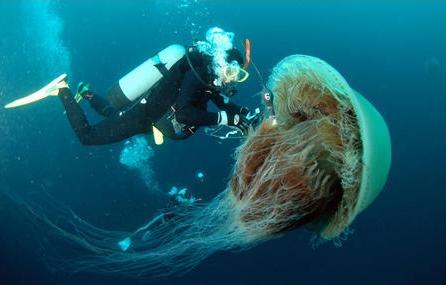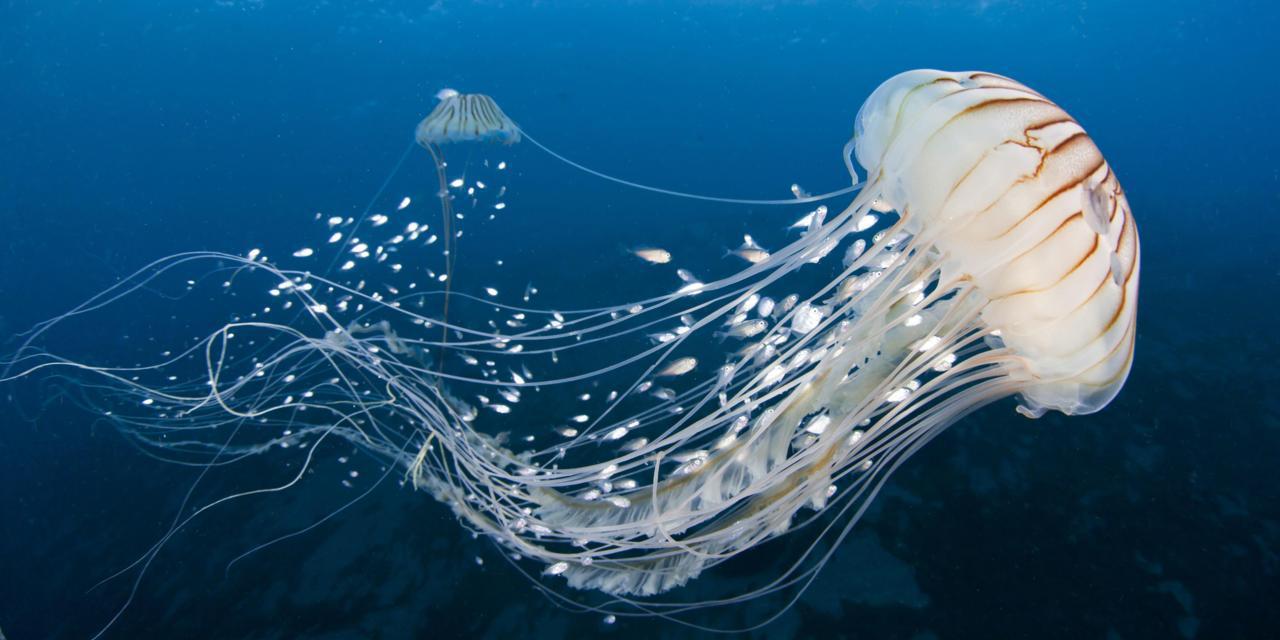The first image is the image on the left, the second image is the image on the right. Assess this claim about the two images: "There is a red jellyfish on one of the iamges.". Correct or not? Answer yes or no. No. 